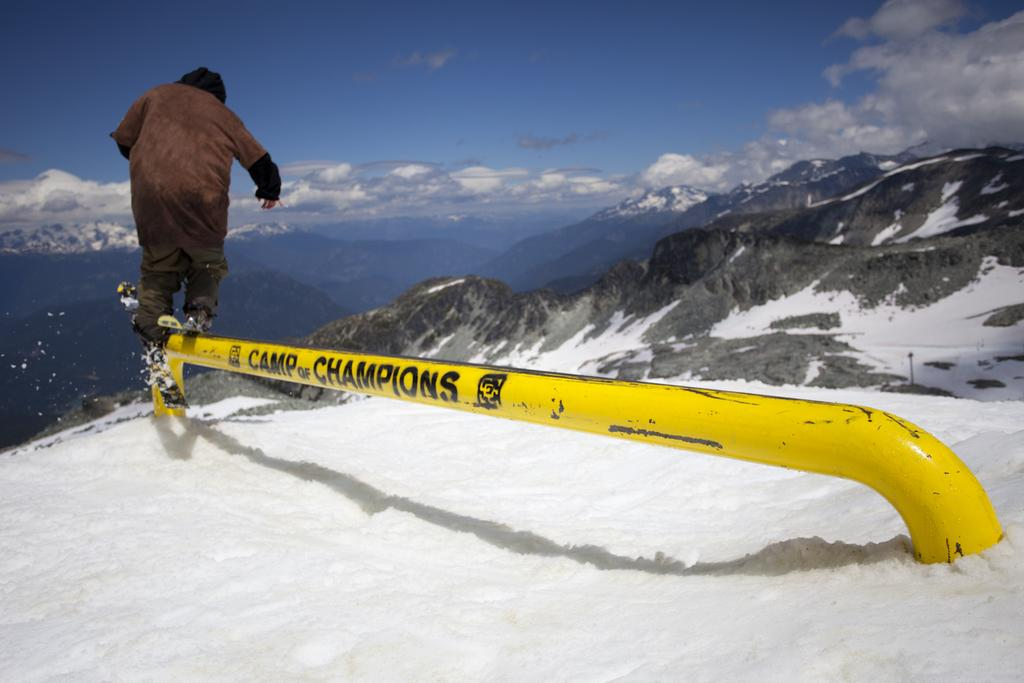What is the person in the image doing? The person is standing on a rod in the image. What is the weather like in the image? There is snow visible in the image, indicating a cold and likely wintery environment. What can be seen in the background of the image? There are mountains and the sky visible in the background of the image. What is the condition of the sky in the image? The sky is visible in the background, and clouds are present in the sky. What type of wren can be seen in the image? There is no wren present in the image. 